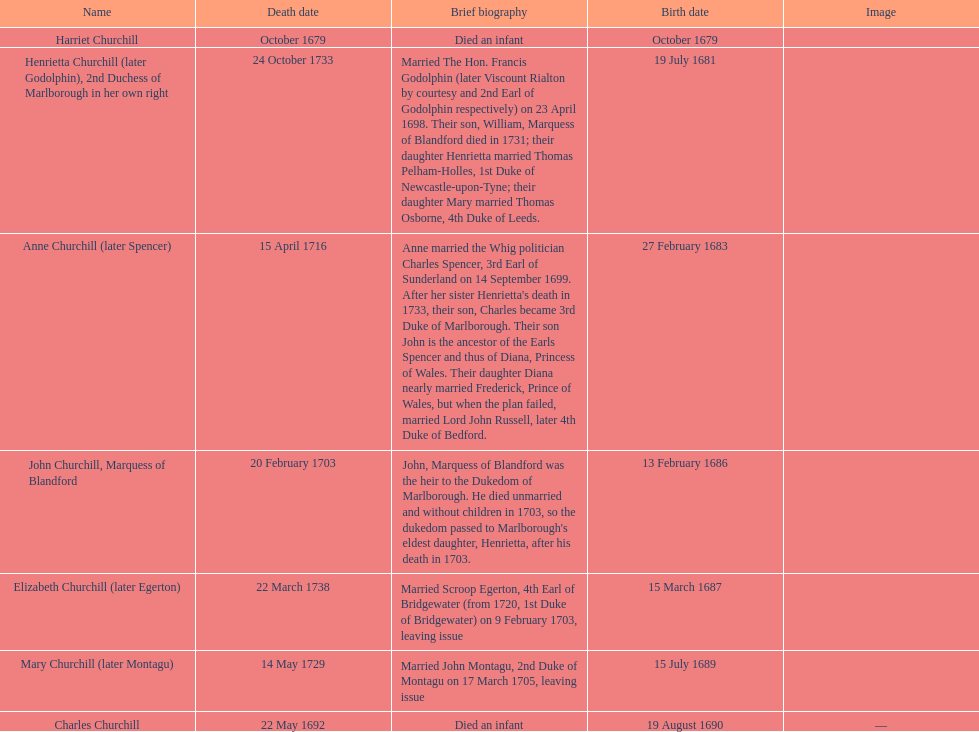Who was born before henrietta churchhill? Harriet Churchill. 